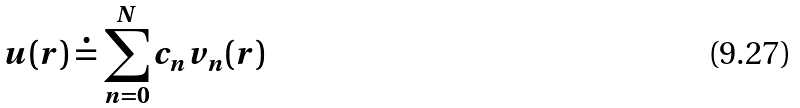<formula> <loc_0><loc_0><loc_500><loc_500>u ( r ) \doteq \sum _ { n = 0 } ^ { N } c _ { n } v _ { n } ( r )</formula> 